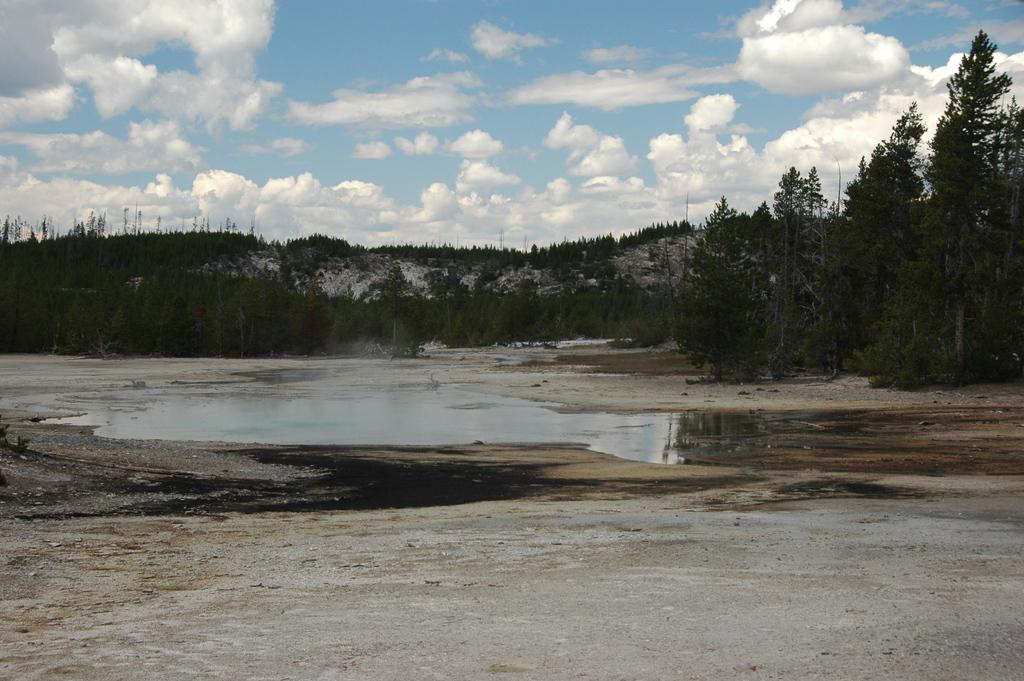What type of terrain is visible at the bottom of the image? There is dry land at the bottom of the image. What can be seen in the background of the image? There is water, trees, plants, a mountain, and clouds in the blue sky in the background of the image. What type of furniture can be seen in the image? There is no furniture present in the image; it features a landscape with dry land, water, trees, plants, a mountain, and clouds. How does the acoustics of the image affect the sound of the wind? The image does not depict any acoustics or sound, so it is not possible to determine how the wind might sound in this scene. 